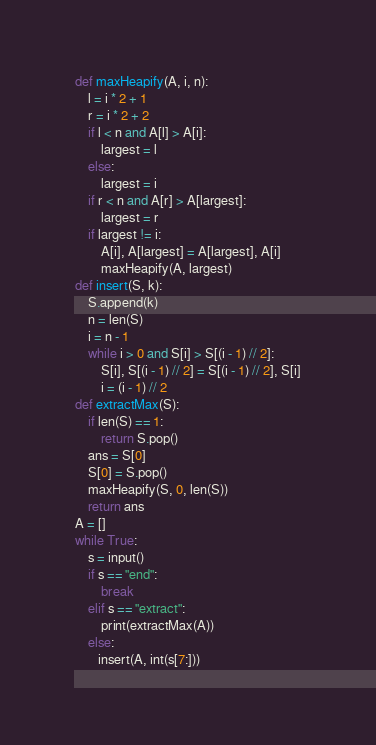<code> <loc_0><loc_0><loc_500><loc_500><_Python_>def maxHeapify(A, i, n):
    l = i * 2 + 1
    r = i * 2 + 2
    if l < n and A[l] > A[i]:
        largest = l
    else:
        largest = i
    if r < n and A[r] > A[largest]:
        largest = r
    if largest != i:
        A[i], A[largest] = A[largest], A[i]
        maxHeapify(A, largest)
def insert(S, k):
    S.append(k)
    n = len(S)
    i = n - 1
    while i > 0 and S[i] > S[(i - 1) // 2]:
        S[i], S[(i - 1) // 2] = S[(i - 1) // 2], S[i]
        i = (i - 1) // 2
def extractMax(S):
    if len(S) == 1:
        return S.pop()
    ans = S[0]
    S[0] = S.pop()
    maxHeapify(S, 0, len(S))
    return ans
A = []
while True:
    s = input()
    if s == "end":
        break
    elif s == "extract":
        print(extractMax(A))
    else:
       insert(A, int(s[7:]))

</code> 